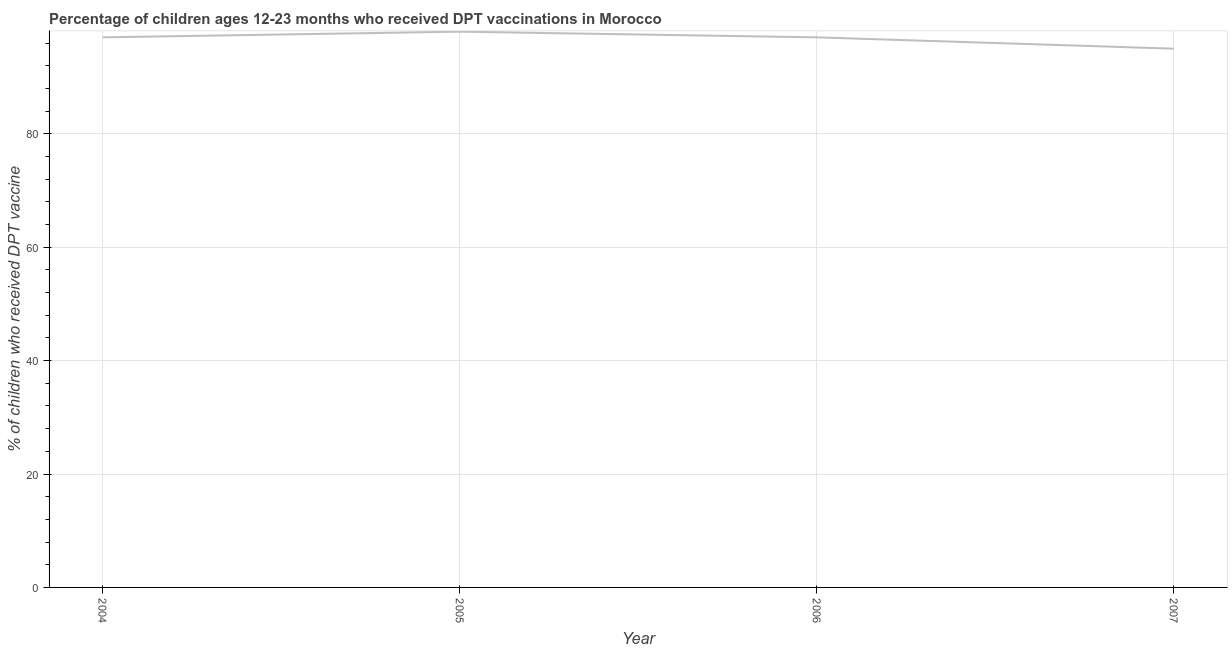What is the percentage of children who received dpt vaccine in 2006?
Your answer should be very brief. 97. Across all years, what is the maximum percentage of children who received dpt vaccine?
Give a very brief answer. 98. Across all years, what is the minimum percentage of children who received dpt vaccine?
Ensure brevity in your answer.  95. What is the sum of the percentage of children who received dpt vaccine?
Offer a terse response. 387. What is the difference between the percentage of children who received dpt vaccine in 2005 and 2007?
Keep it short and to the point. 3. What is the average percentage of children who received dpt vaccine per year?
Your response must be concise. 96.75. What is the median percentage of children who received dpt vaccine?
Your answer should be very brief. 97. In how many years, is the percentage of children who received dpt vaccine greater than 72 %?
Offer a terse response. 4. Do a majority of the years between 2005 and 2007 (inclusive) have percentage of children who received dpt vaccine greater than 44 %?
Offer a very short reply. Yes. What is the ratio of the percentage of children who received dpt vaccine in 2005 to that in 2006?
Provide a short and direct response. 1.01. Is the sum of the percentage of children who received dpt vaccine in 2004 and 2006 greater than the maximum percentage of children who received dpt vaccine across all years?
Keep it short and to the point. Yes. What is the difference between the highest and the lowest percentage of children who received dpt vaccine?
Provide a succinct answer. 3. In how many years, is the percentage of children who received dpt vaccine greater than the average percentage of children who received dpt vaccine taken over all years?
Offer a very short reply. 3. How many lines are there?
Ensure brevity in your answer.  1. What is the difference between two consecutive major ticks on the Y-axis?
Offer a terse response. 20. Are the values on the major ticks of Y-axis written in scientific E-notation?
Make the answer very short. No. Does the graph contain any zero values?
Offer a very short reply. No. What is the title of the graph?
Provide a succinct answer. Percentage of children ages 12-23 months who received DPT vaccinations in Morocco. What is the label or title of the Y-axis?
Ensure brevity in your answer.  % of children who received DPT vaccine. What is the % of children who received DPT vaccine in 2004?
Make the answer very short. 97. What is the % of children who received DPT vaccine in 2005?
Offer a terse response. 98. What is the % of children who received DPT vaccine of 2006?
Make the answer very short. 97. What is the % of children who received DPT vaccine in 2007?
Offer a terse response. 95. What is the difference between the % of children who received DPT vaccine in 2004 and 2006?
Keep it short and to the point. 0. What is the difference between the % of children who received DPT vaccine in 2004 and 2007?
Keep it short and to the point. 2. What is the difference between the % of children who received DPT vaccine in 2005 and 2007?
Offer a terse response. 3. What is the difference between the % of children who received DPT vaccine in 2006 and 2007?
Offer a terse response. 2. What is the ratio of the % of children who received DPT vaccine in 2004 to that in 2005?
Your response must be concise. 0.99. What is the ratio of the % of children who received DPT vaccine in 2004 to that in 2006?
Ensure brevity in your answer.  1. What is the ratio of the % of children who received DPT vaccine in 2005 to that in 2007?
Your answer should be compact. 1.03. 